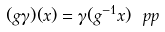<formula> <loc_0><loc_0><loc_500><loc_500>( g \gamma ) ( x ) = \gamma ( g ^ { - 1 } x ) \ p p</formula> 